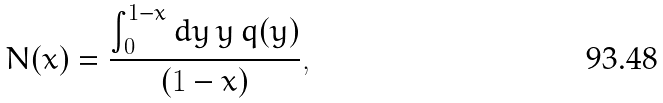Convert formula to latex. <formula><loc_0><loc_0><loc_500><loc_500>N ( x ) = \frac { \int _ { 0 } ^ { 1 - x } d y \, y \, q ( y ) } { ( 1 - x ) } ,</formula> 